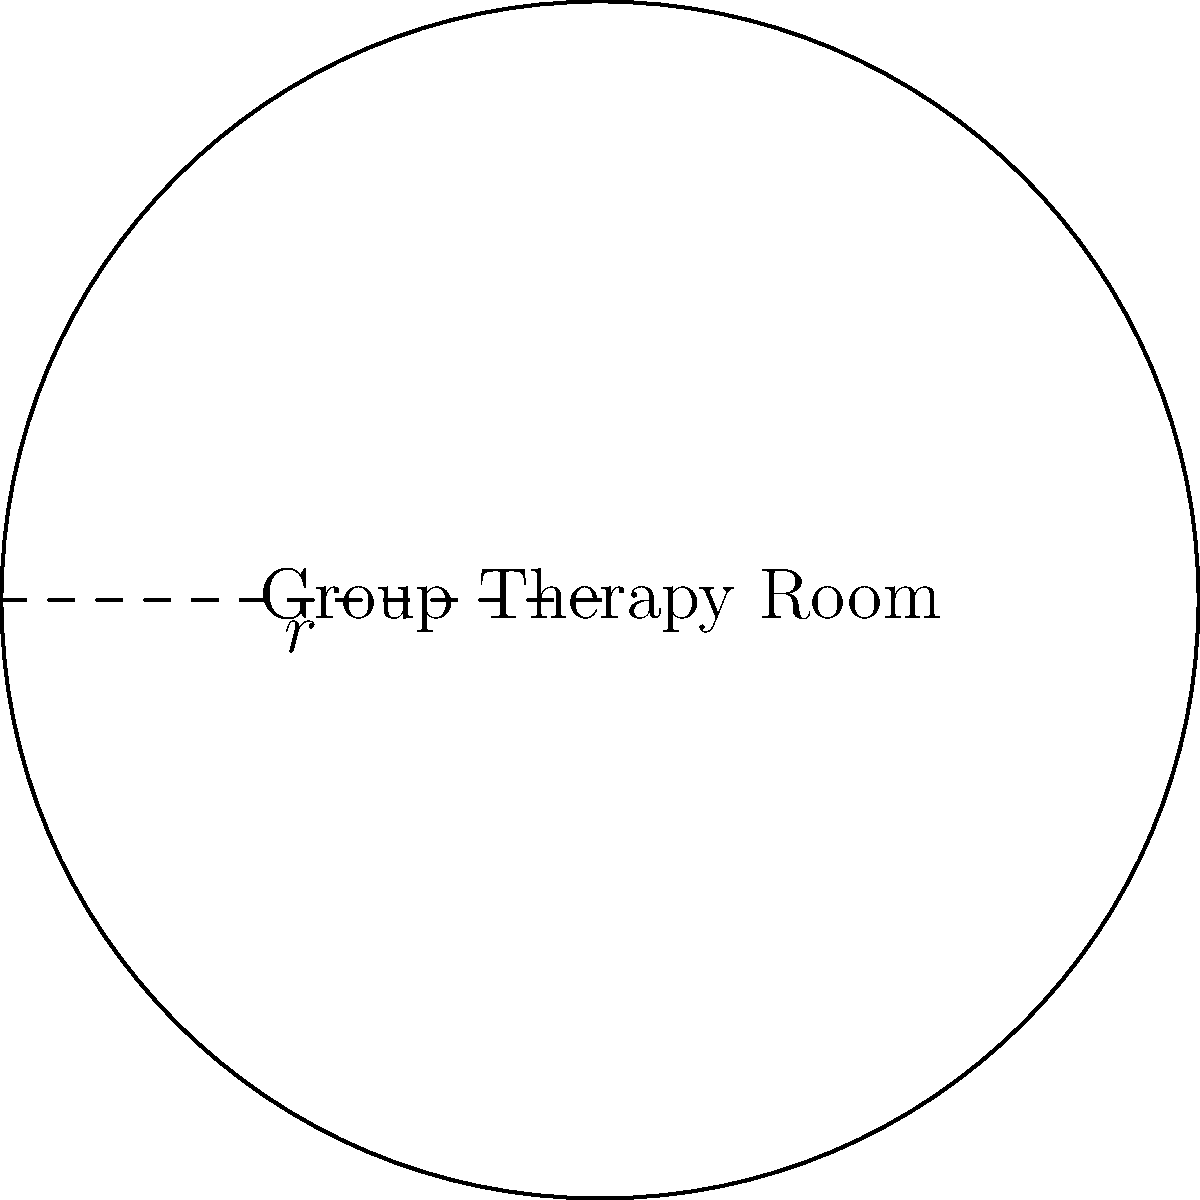In a circular group therapy room designed for young offenders, the radius is 5 meters. What is the total floor area of this room? To find the area of a circular room, we need to use the formula for the area of a circle:

1. The formula for the area of a circle is $A = \pi r^2$, where $A$ is the area and $r$ is the radius.

2. We are given that the radius is 5 meters.

3. Let's substitute this into our formula:
   $A = \pi (5)^2$

4. Simplify the exponent:
   $A = \pi (25)$

5. Multiply:
   $A = 25\pi$ square meters

6. If we need to give a decimal approximation, we can use $\pi \approx 3.14159$:
   $A \approx 25 * 3.14159 \approx 78.54$ square meters

Therefore, the total floor area of the circular group therapy room is $25\pi$ or approximately 78.54 square meters.
Answer: $25\pi$ m² (or approximately 78.54 m²) 